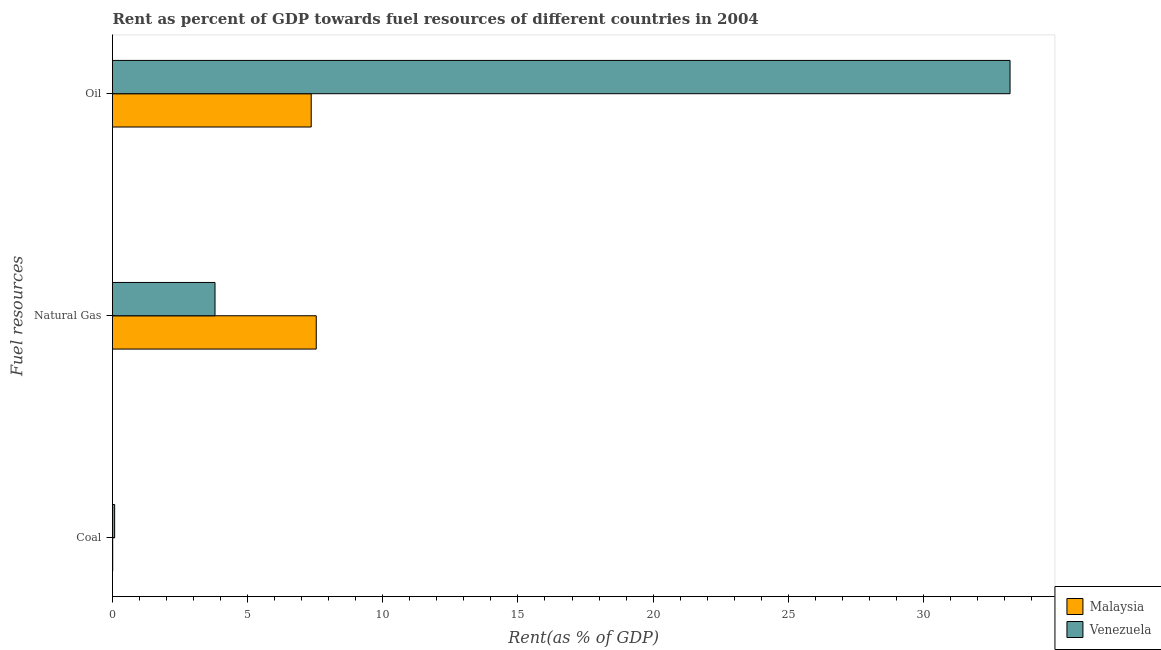How many different coloured bars are there?
Your answer should be compact. 2. How many groups of bars are there?
Make the answer very short. 3. Are the number of bars per tick equal to the number of legend labels?
Offer a terse response. Yes. How many bars are there on the 2nd tick from the top?
Your answer should be very brief. 2. How many bars are there on the 2nd tick from the bottom?
Your answer should be very brief. 2. What is the label of the 1st group of bars from the top?
Offer a terse response. Oil. What is the rent towards natural gas in Malaysia?
Offer a terse response. 7.54. Across all countries, what is the maximum rent towards natural gas?
Offer a very short reply. 7.54. Across all countries, what is the minimum rent towards natural gas?
Keep it short and to the point. 3.79. In which country was the rent towards coal maximum?
Provide a short and direct response. Venezuela. In which country was the rent towards oil minimum?
Your response must be concise. Malaysia. What is the total rent towards natural gas in the graph?
Make the answer very short. 11.33. What is the difference between the rent towards coal in Malaysia and that in Venezuela?
Your answer should be very brief. -0.07. What is the difference between the rent towards coal in Malaysia and the rent towards oil in Venezuela?
Your answer should be compact. -33.2. What is the average rent towards natural gas per country?
Your answer should be compact. 5.67. What is the difference between the rent towards coal and rent towards oil in Malaysia?
Give a very brief answer. -7.34. What is the ratio of the rent towards oil in Venezuela to that in Malaysia?
Provide a short and direct response. 4.52. What is the difference between the highest and the second highest rent towards coal?
Provide a short and direct response. 0.07. What is the difference between the highest and the lowest rent towards coal?
Give a very brief answer. 0.07. What does the 2nd bar from the top in Natural Gas represents?
Your answer should be very brief. Malaysia. What does the 1st bar from the bottom in Natural Gas represents?
Offer a terse response. Malaysia. What is the difference between two consecutive major ticks on the X-axis?
Offer a very short reply. 5. Are the values on the major ticks of X-axis written in scientific E-notation?
Give a very brief answer. No. Does the graph contain any zero values?
Your response must be concise. No. Where does the legend appear in the graph?
Ensure brevity in your answer.  Bottom right. How many legend labels are there?
Give a very brief answer. 2. What is the title of the graph?
Keep it short and to the point. Rent as percent of GDP towards fuel resources of different countries in 2004. What is the label or title of the X-axis?
Make the answer very short. Rent(as % of GDP). What is the label or title of the Y-axis?
Provide a short and direct response. Fuel resources. What is the Rent(as % of GDP) in Malaysia in Coal?
Offer a very short reply. 0.01. What is the Rent(as % of GDP) in Venezuela in Coal?
Your answer should be very brief. 0.08. What is the Rent(as % of GDP) of Malaysia in Natural Gas?
Keep it short and to the point. 7.54. What is the Rent(as % of GDP) of Venezuela in Natural Gas?
Provide a succinct answer. 3.79. What is the Rent(as % of GDP) of Malaysia in Oil?
Ensure brevity in your answer.  7.35. What is the Rent(as % of GDP) of Venezuela in Oil?
Offer a very short reply. 33.21. Across all Fuel resources, what is the maximum Rent(as % of GDP) of Malaysia?
Give a very brief answer. 7.54. Across all Fuel resources, what is the maximum Rent(as % of GDP) of Venezuela?
Keep it short and to the point. 33.21. Across all Fuel resources, what is the minimum Rent(as % of GDP) of Malaysia?
Keep it short and to the point. 0.01. Across all Fuel resources, what is the minimum Rent(as % of GDP) of Venezuela?
Offer a very short reply. 0.08. What is the total Rent(as % of GDP) of Malaysia in the graph?
Make the answer very short. 14.9. What is the total Rent(as % of GDP) of Venezuela in the graph?
Keep it short and to the point. 37.08. What is the difference between the Rent(as % of GDP) of Malaysia in Coal and that in Natural Gas?
Offer a terse response. -7.53. What is the difference between the Rent(as % of GDP) of Venezuela in Coal and that in Natural Gas?
Ensure brevity in your answer.  -3.71. What is the difference between the Rent(as % of GDP) of Malaysia in Coal and that in Oil?
Your response must be concise. -7.34. What is the difference between the Rent(as % of GDP) in Venezuela in Coal and that in Oil?
Offer a very short reply. -33.13. What is the difference between the Rent(as % of GDP) of Malaysia in Natural Gas and that in Oil?
Make the answer very short. 0.19. What is the difference between the Rent(as % of GDP) in Venezuela in Natural Gas and that in Oil?
Your answer should be compact. -29.41. What is the difference between the Rent(as % of GDP) of Malaysia in Coal and the Rent(as % of GDP) of Venezuela in Natural Gas?
Offer a very short reply. -3.79. What is the difference between the Rent(as % of GDP) in Malaysia in Coal and the Rent(as % of GDP) in Venezuela in Oil?
Give a very brief answer. -33.2. What is the difference between the Rent(as % of GDP) of Malaysia in Natural Gas and the Rent(as % of GDP) of Venezuela in Oil?
Offer a terse response. -25.67. What is the average Rent(as % of GDP) of Malaysia per Fuel resources?
Provide a short and direct response. 4.97. What is the average Rent(as % of GDP) in Venezuela per Fuel resources?
Provide a short and direct response. 12.36. What is the difference between the Rent(as % of GDP) of Malaysia and Rent(as % of GDP) of Venezuela in Coal?
Provide a short and direct response. -0.07. What is the difference between the Rent(as % of GDP) of Malaysia and Rent(as % of GDP) of Venezuela in Natural Gas?
Make the answer very short. 3.75. What is the difference between the Rent(as % of GDP) in Malaysia and Rent(as % of GDP) in Venezuela in Oil?
Keep it short and to the point. -25.85. What is the ratio of the Rent(as % of GDP) of Malaysia in Coal to that in Natural Gas?
Give a very brief answer. 0. What is the ratio of the Rent(as % of GDP) in Venezuela in Coal to that in Natural Gas?
Keep it short and to the point. 0.02. What is the ratio of the Rent(as % of GDP) of Venezuela in Coal to that in Oil?
Your response must be concise. 0. What is the ratio of the Rent(as % of GDP) of Malaysia in Natural Gas to that in Oil?
Offer a very short reply. 1.03. What is the ratio of the Rent(as % of GDP) of Venezuela in Natural Gas to that in Oil?
Ensure brevity in your answer.  0.11. What is the difference between the highest and the second highest Rent(as % of GDP) in Malaysia?
Offer a very short reply. 0.19. What is the difference between the highest and the second highest Rent(as % of GDP) in Venezuela?
Ensure brevity in your answer.  29.41. What is the difference between the highest and the lowest Rent(as % of GDP) of Malaysia?
Ensure brevity in your answer.  7.53. What is the difference between the highest and the lowest Rent(as % of GDP) of Venezuela?
Give a very brief answer. 33.13. 